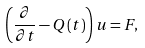<formula> <loc_0><loc_0><loc_500><loc_500>\left ( \frac { \partial } { \partial t } - Q \left ( t \right ) \right ) u = F ,</formula> 